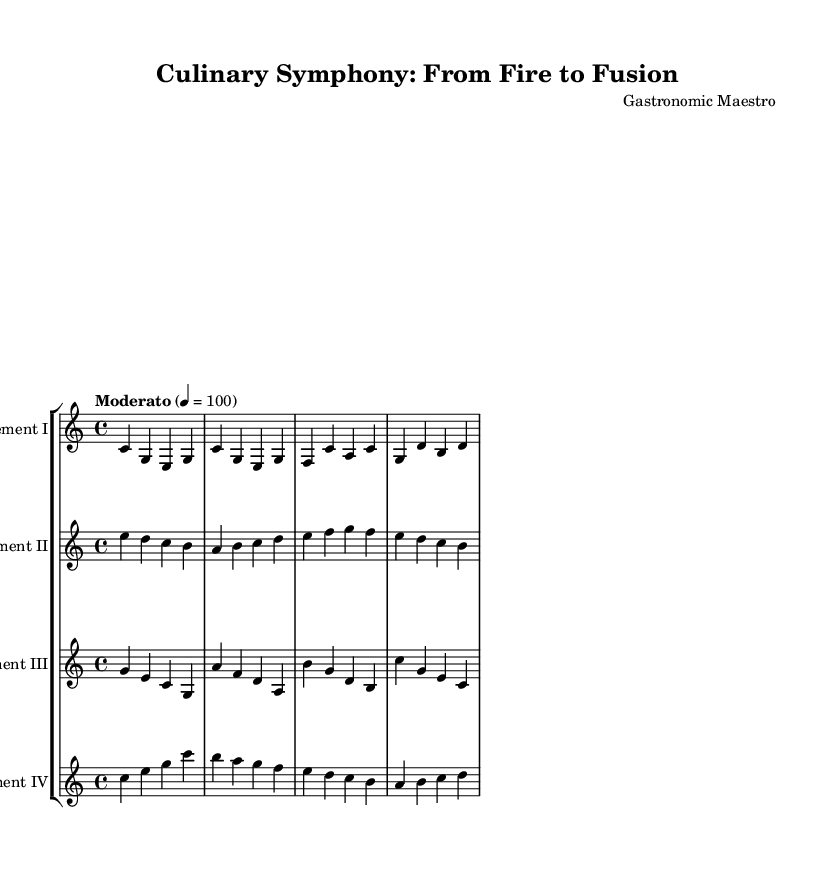What is the key signature of this music? The key signature is indicated at the beginning of the sheet music, and it displays no sharps or flats, which corresponds to C major.
Answer: C major What is the time signature for this symphony? The time signature is specified at the beginning of the music, presented as 4/4, meaning there are four beats in each measure.
Answer: 4/4 What is the tempo marking for this piece? The tempo marking shows "Moderato" with a metronome marking of 100, signifying a moderately paced performance at 100 beats per minute.
Answer: Moderato Which movement represents the Industrial Revolution? The movement is identified by the instrument name "Movement III," which corresponds to the section labeled with the musical phrases characteristic of that era.
Answer: Movement III How many movements are there in this symphony? The number of movements can be counted based on the separate staves provided, each labeled accordingly; there are four distinct movements presented.
Answer: Four What instrument is featured in the first movement? The first movement is labeled as "Movement I," which signifies that it is performed by an unspecified orchestral instrument depicted on the first staff.
Answer: Movement I Which historical period does the second movement represent? The second movement, labeled as "Movement II," depicts the medieval era through its musical structure and thematic content related to cauldron cooking techniques.
Answer: Medieval 